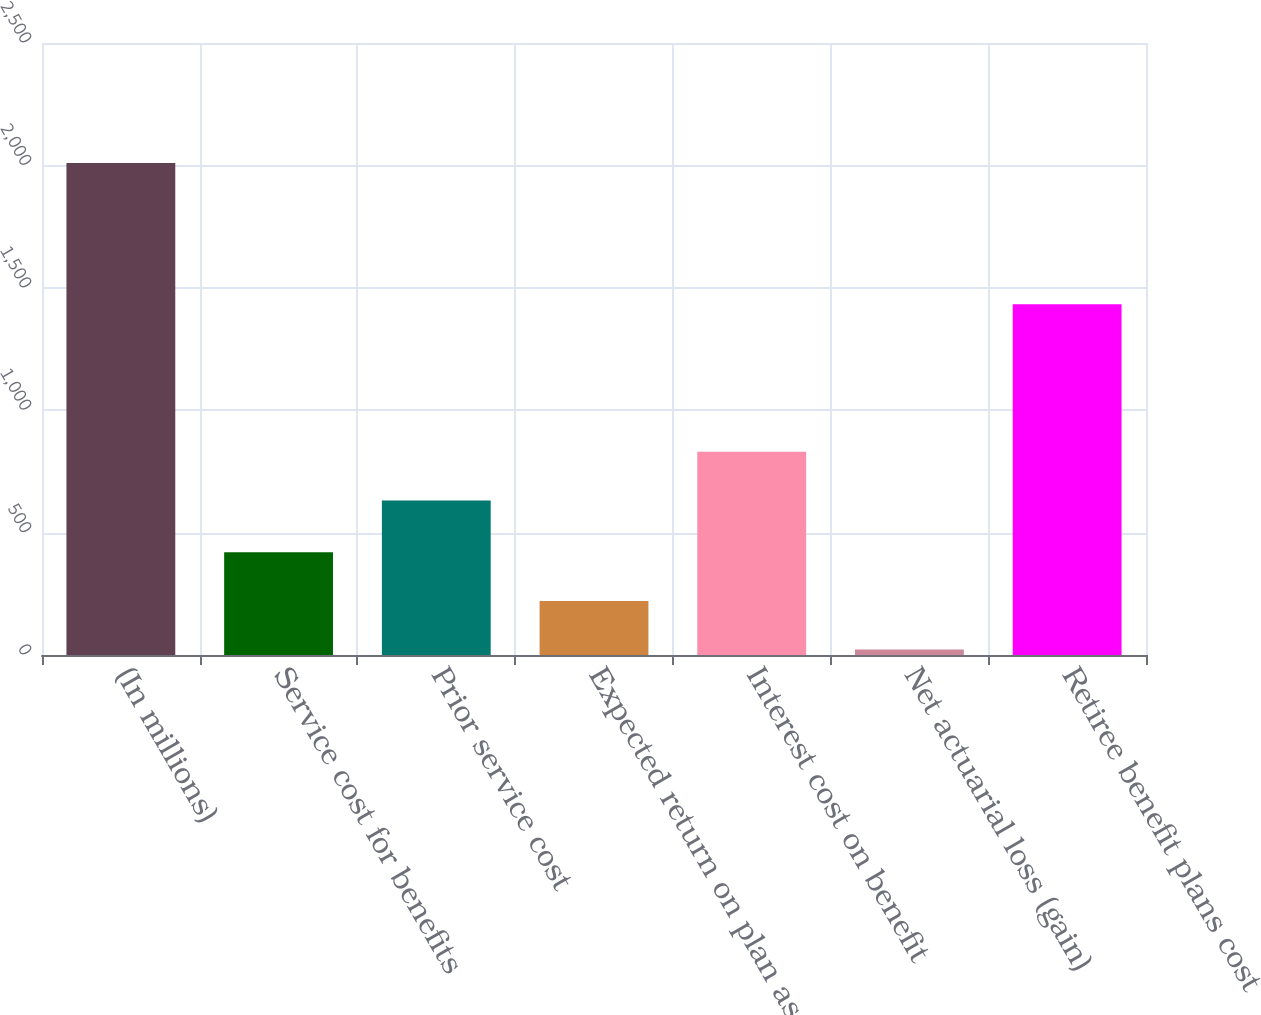Convert chart to OTSL. <chart><loc_0><loc_0><loc_500><loc_500><bar_chart><fcel>(In millions)<fcel>Service cost for benefits<fcel>Prior service cost<fcel>Expected return on plan assets<fcel>Interest cost on benefit<fcel>Net actuarial loss (gain)<fcel>Retiree benefit plans cost<nl><fcel>2010<fcel>419.6<fcel>631<fcel>220.8<fcel>829.8<fcel>22<fcel>1433<nl></chart> 